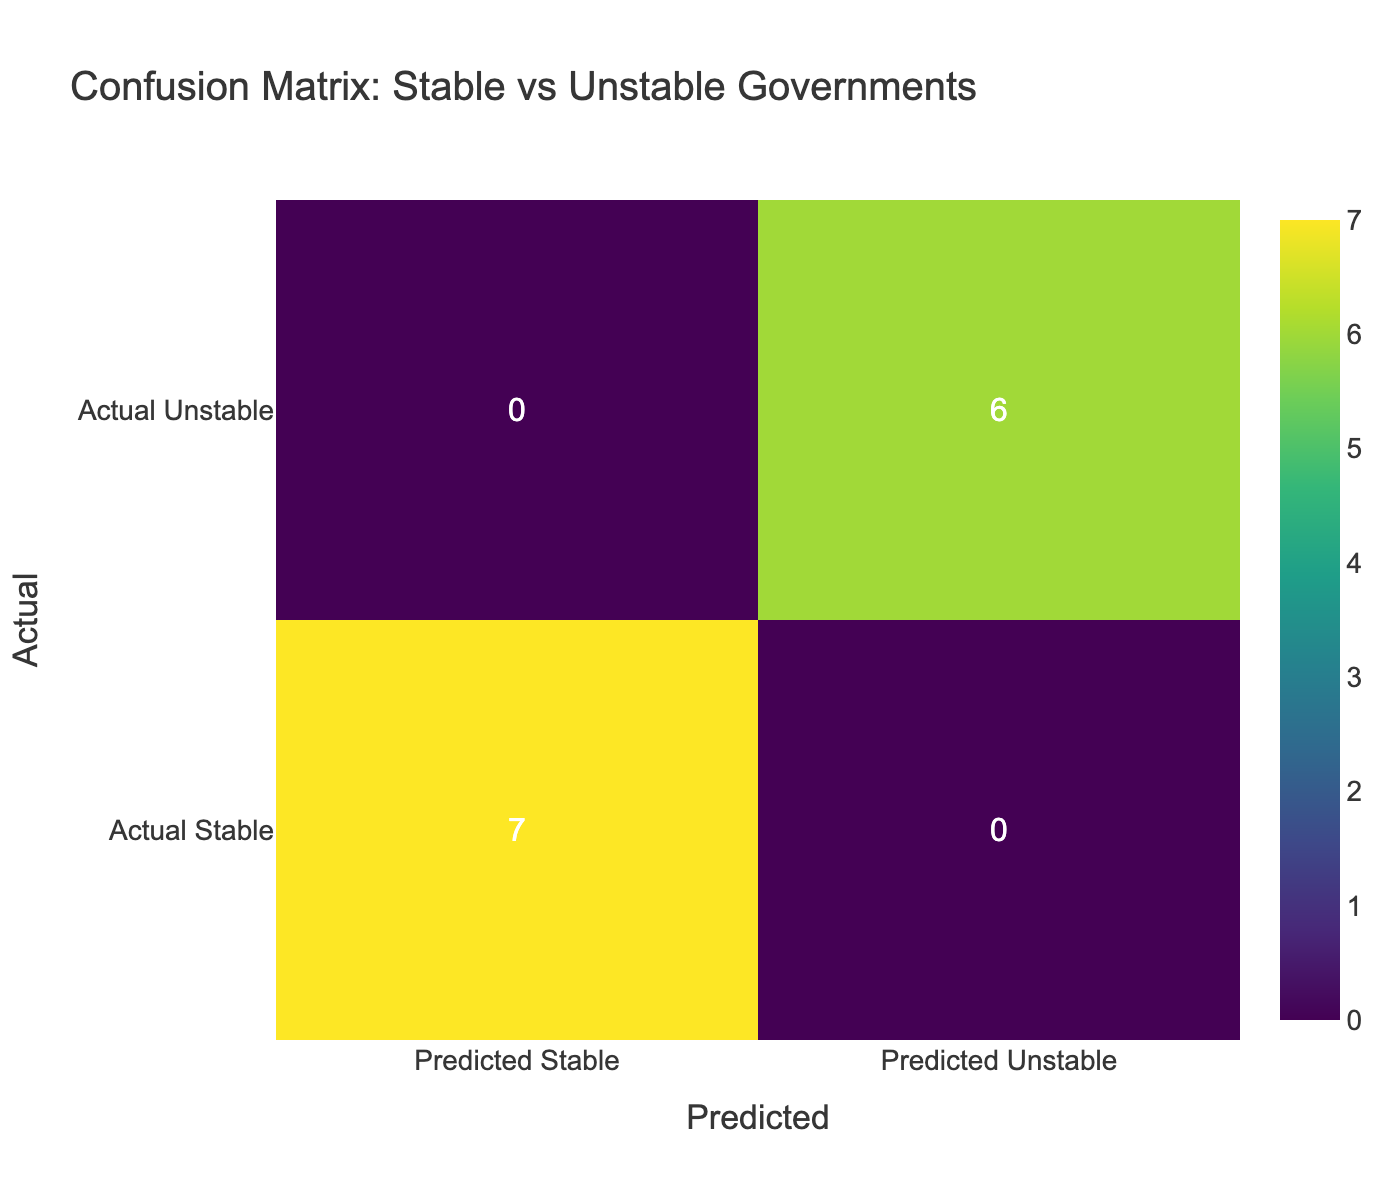What is the number of true positives in the confusion matrix? The true positives are the instances where actual governments are stable and predicted as stable. Referring to the table, the stable governments listed are Canada, Germany, Japan, Australia, Sweden, Singapore, and Switzerland, totalling 7, but only 6 are predicted stable. Thus, the true positives are 6.
Answer: 6 What is the number of false positives? False positives occur when unstable governments are predicted as stable. From the table, the unstable governments are Venezuela, Somalia, Afghanistan, Libya, Syria, and Haiti. None of these are predicted as stable, so the count of false positives is 0.
Answer: 0 What is the number of actual unstable governments in the dataset? Upon examining the table, there are 6 governments listed as unstable: Venezuela, Somalia, Afghanistan, Libya, Syria, and Haiti. Thus, the total number of actual unstable governments is 6.
Answer: 6 What is the total number of governments predicted as unstable? The total of predictions for unstable governments can be obtained by counting the instances in the 'Predicted Unstable' column. From the data, it shows that 6 governments are predicted as unstable.
Answer: 6 Is it true that all stable government predictions resulted in true positives? To determine this, we check if any stable government is misclassified as unstable. From the stable governments listed (Canada, Germany, Japan, Australia, Sweden, Singapore, Switzerland), they are all predicted as stable, hence confirming true positives with no discrepancies. Thus, the statement is true.
Answer: Yes What is the proportion of true negatives to false negatives? True negatives are the instances where unstable governments are correctly predicted as unstable. Reviewing the data, only Somalia, Venezuela, Afghanistan, Libya, Syria, and Haiti are classified as unstable and predicted as unstable (6 true negatives), while there are 0 false negatives (where stable governments are incorrectly predicted as unstable), resulting in a proportion of 6 to 0. This could be considered undefined, but simply, there are many true negatives and no false negatives in this context.
Answer: Undefined How many total governments are represented in the confusion matrix? The total number of governments in the dataset is the sum of stable and unstable columns. There are 7 stable and 6 unstable governments, which equals 13 total governments in the confusion matrix. Therefore, the total number of governments is 13.
Answer: 13 How many governments were misclassified as unstable? Misclassified governments occur when stable ones are predicted as unstable. There are no stable governments counted in the 'Predicted Unstable' category, so the count of misclassified governments is 0.
Answer: 0 What is the difference between true positives and true negatives? True positives are the correctly predicted stable governments (which are 6), and true negatives are the correctly predicted unstable governments (which are also 6). Thus, the difference is 6 - 6 = 0.
Answer: 0 